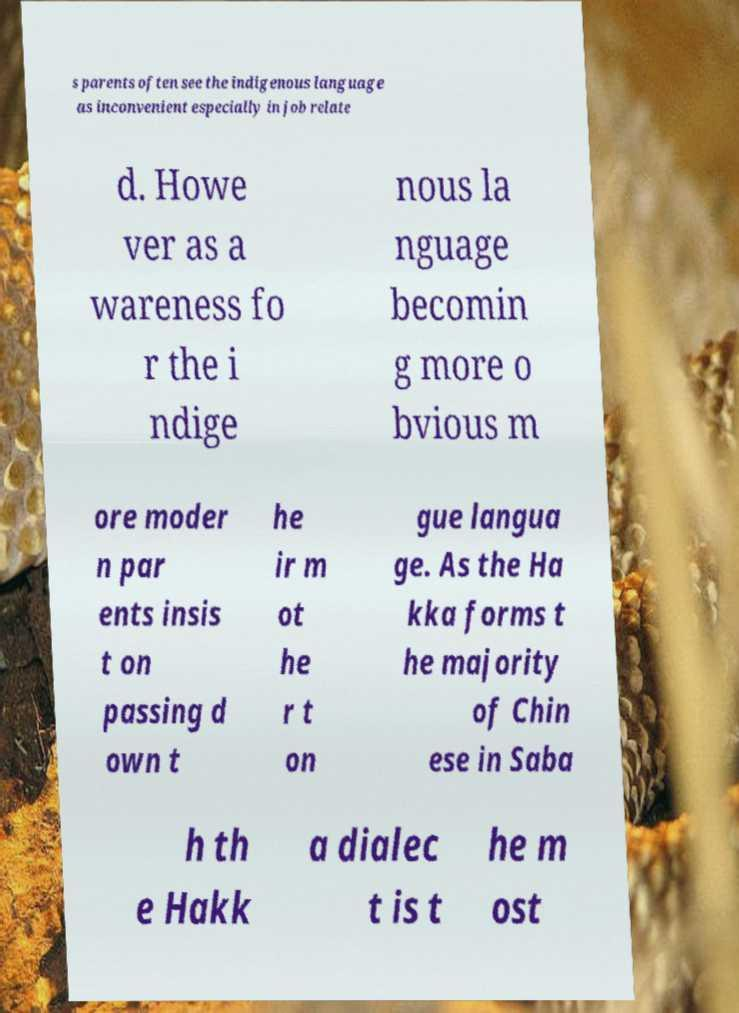Could you assist in decoding the text presented in this image and type it out clearly? s parents often see the indigenous language as inconvenient especially in job relate d. Howe ver as a wareness fo r the i ndige nous la nguage becomin g more o bvious m ore moder n par ents insis t on passing d own t he ir m ot he r t on gue langua ge. As the Ha kka forms t he majority of Chin ese in Saba h th e Hakk a dialec t is t he m ost 